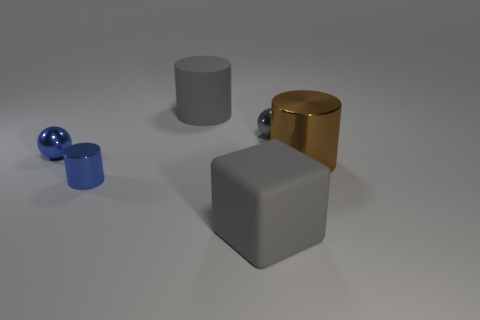How many objects are tiny blue metal balls or spheres in front of the tiny gray metal thing?
Provide a short and direct response. 1. There is a block; does it have the same color as the small object in front of the brown cylinder?
Provide a short and direct response. No. There is a cylinder that is on the left side of the large metallic thing and in front of the blue metallic sphere; how big is it?
Offer a terse response. Small. There is a gray rubber cylinder; are there any small gray objects to the left of it?
Your answer should be very brief. No. Are there any gray metallic objects that are left of the sphere to the left of the big rubber block?
Your response must be concise. No. Is the number of large cylinders that are to the right of the big brown cylinder the same as the number of brown cylinders in front of the tiny blue cylinder?
Make the answer very short. Yes. There is another cylinder that is made of the same material as the brown cylinder; what color is it?
Your response must be concise. Blue. Is there a cyan cylinder that has the same material as the big brown thing?
Your answer should be compact. No. What number of objects are large red metallic things or brown shiny things?
Your answer should be very brief. 1. Do the big gray cube and the big gray thing behind the large block have the same material?
Your response must be concise. Yes. 